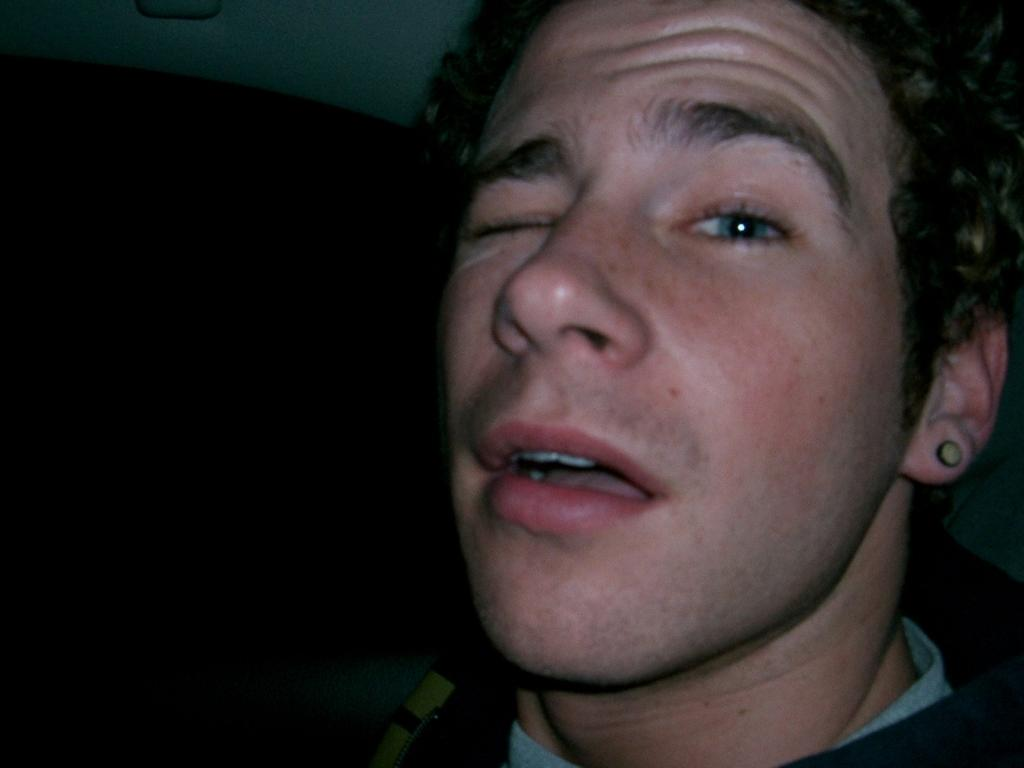What is the main subject of the image? There is a person in the image. What is the person doing in the image? The person is winking an eye. What type of bomb is being used to create friction in the image? There is no bomb or friction present in the image; it only features a person winking an eye. 